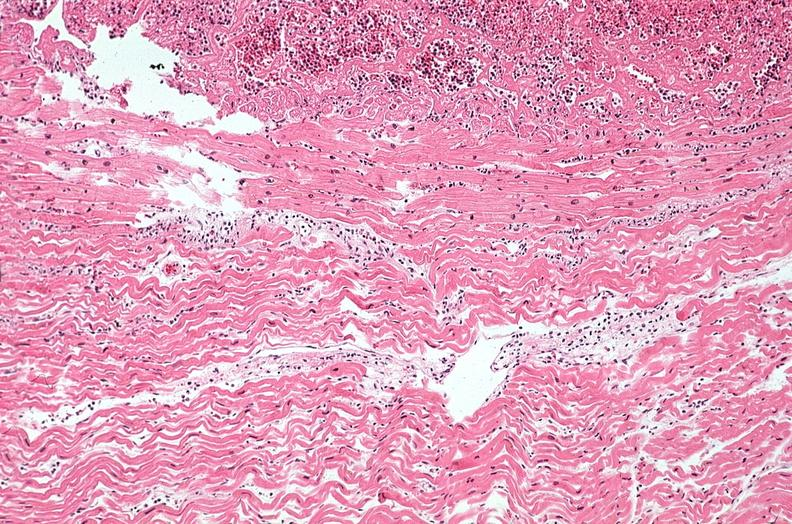s heart present?
Answer the question using a single word or phrase. Yes 